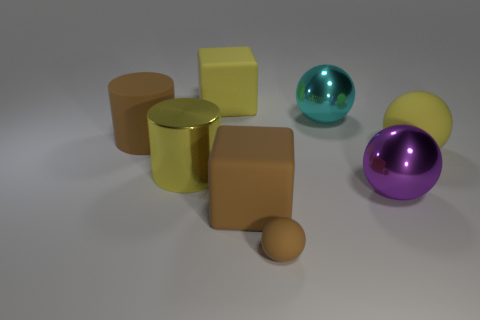How does the composition of the objects contribute to the overall aesthetic? The composition of the objects, with a variety of geometric shapes and reflective surfaces, creates a balanced and harmonious arrangement. The use of different colors and materials adds visual interest and depth, while the soft lighting highlights the forms and textures, resulting in a pleasing, modern aesthetic. What emotions or ideas might this arrangement evoke for a viewer? This arrangement may evoke a sense of calm and order due to the symmetrical balance and the clear separation between objects. It could also suggest notions of modernity and simplicity, relating to minimalist design principles. 